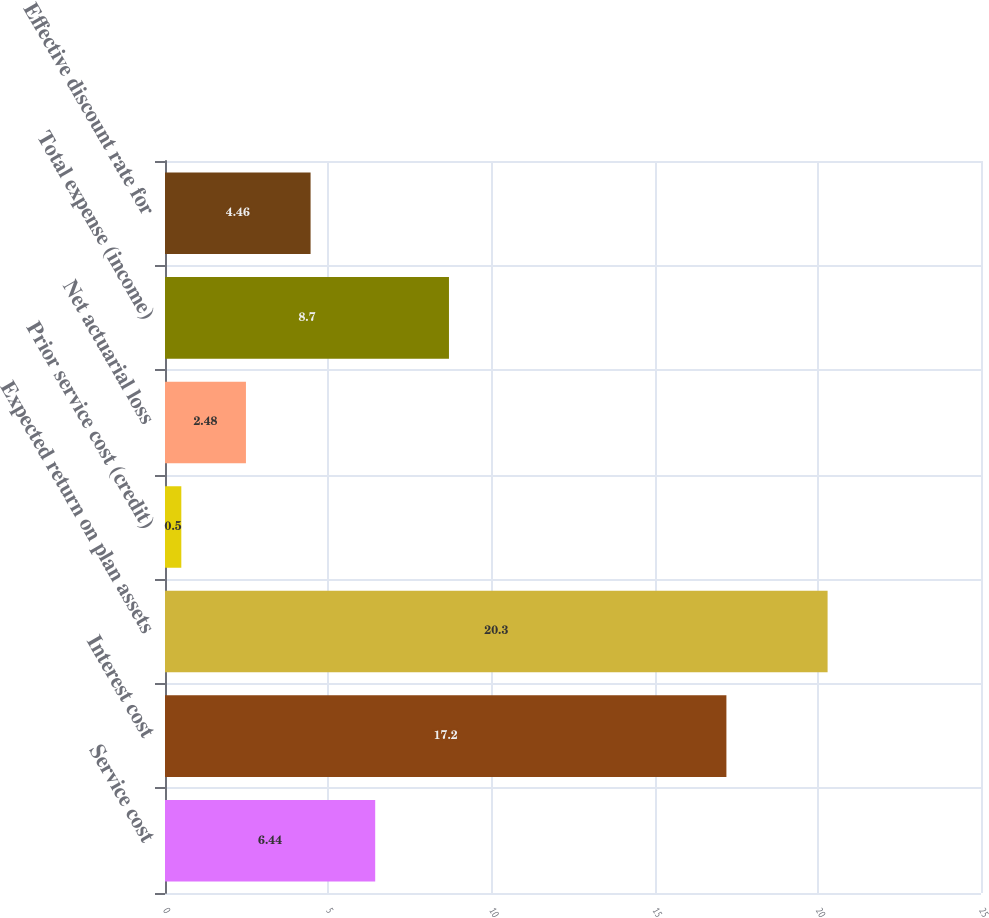Convert chart. <chart><loc_0><loc_0><loc_500><loc_500><bar_chart><fcel>Service cost<fcel>Interest cost<fcel>Expected return on plan assets<fcel>Prior service cost (credit)<fcel>Net actuarial loss<fcel>Total expense (income)<fcel>Effective discount rate for<nl><fcel>6.44<fcel>17.2<fcel>20.3<fcel>0.5<fcel>2.48<fcel>8.7<fcel>4.46<nl></chart> 